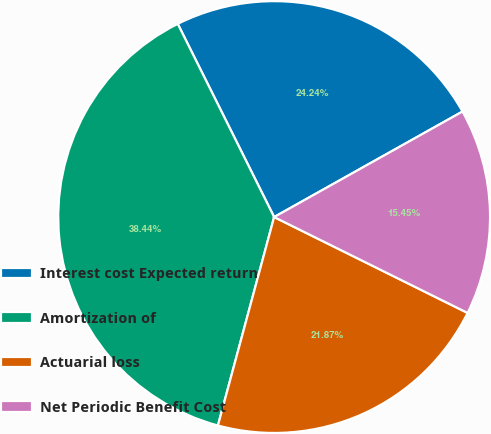<chart> <loc_0><loc_0><loc_500><loc_500><pie_chart><fcel>Interest cost Expected return<fcel>Amortization of<fcel>Actuarial loss<fcel>Net Periodic Benefit Cost<nl><fcel>24.24%<fcel>38.44%<fcel>21.87%<fcel>15.45%<nl></chart> 